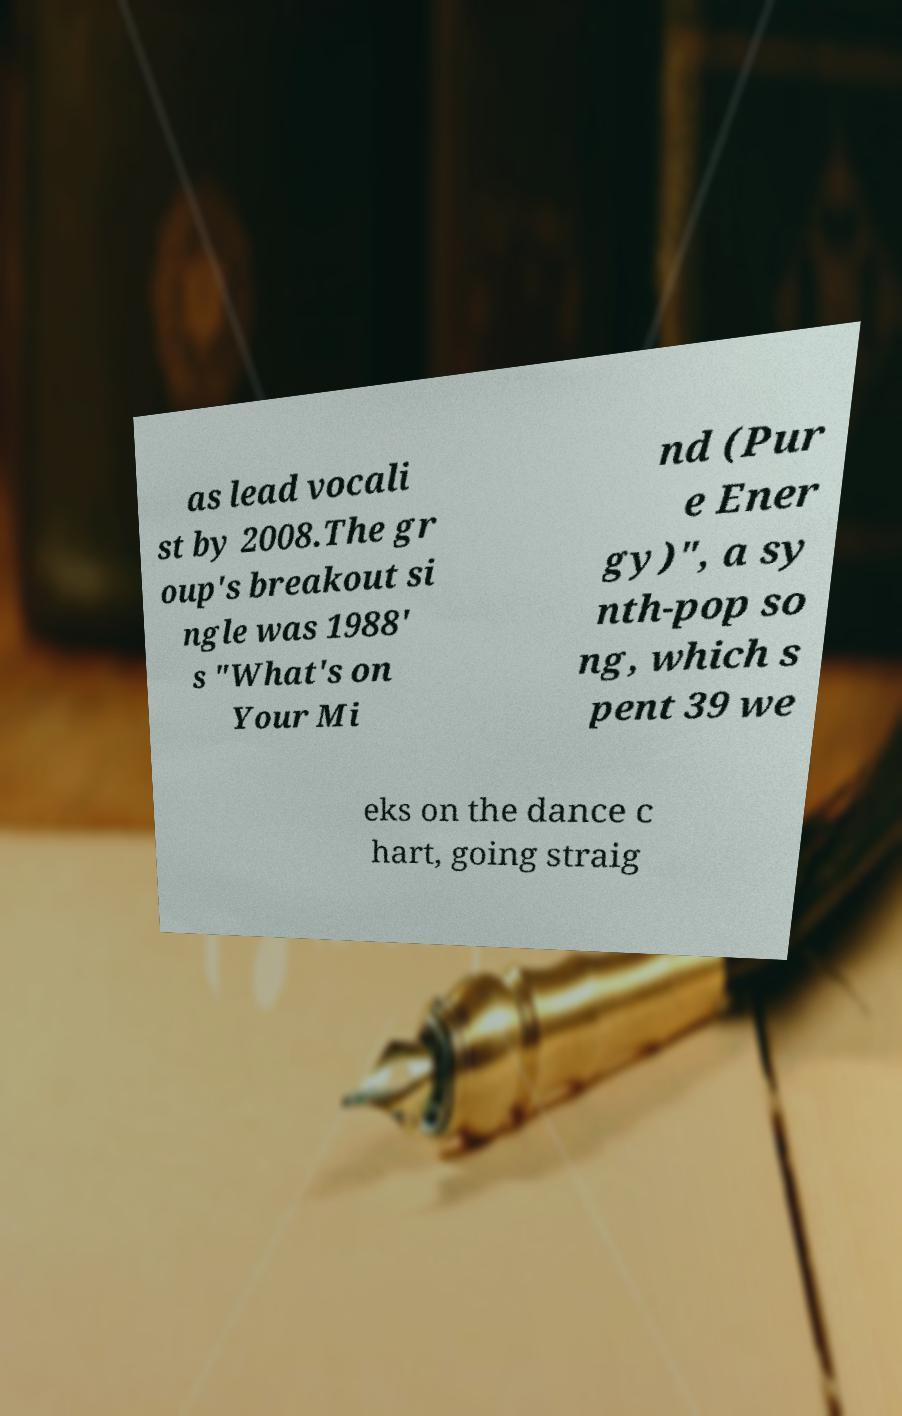Can you accurately transcribe the text from the provided image for me? as lead vocali st by 2008.The gr oup's breakout si ngle was 1988' s "What's on Your Mi nd (Pur e Ener gy)", a sy nth-pop so ng, which s pent 39 we eks on the dance c hart, going straig 